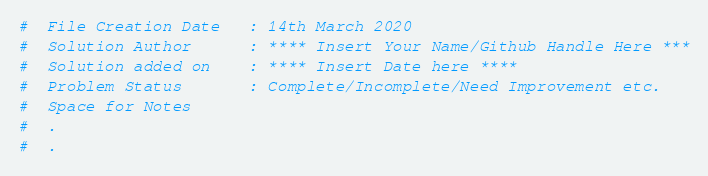<code> <loc_0><loc_0><loc_500><loc_500><_Python_>#  File Creation Date   : 14th March 2020
#  Solution Author      : **** Insert Your Name/Github Handle Here ***
#  Solution added on    : **** Insert Date here ****
#  Problem Status       : Complete/Incomplete/Need Improvement etc. 
#  Space for Notes
#  .
#  .
</code> 